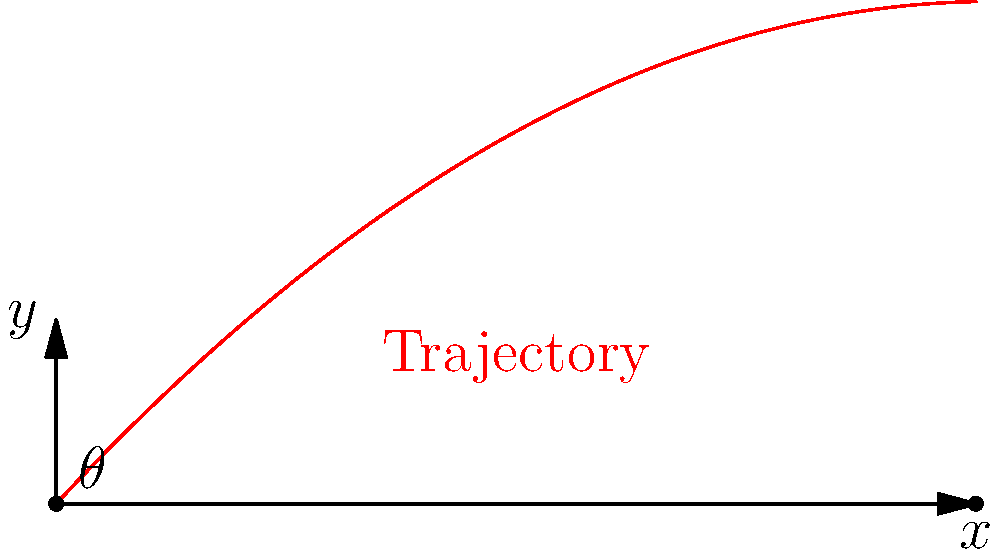As a shooting coach, you're training a Paralympic athlete for a long-range target event. The athlete needs to hit a target 500 meters away using a specialized air rifle with an initial velocity of 100 m/s. Neglecting air resistance, what is the optimal firing angle (in degrees) to hit the target? To solve this problem, we'll use the equation for the optimal angle when air resistance is neglected:

$$\theta = \frac{1}{2}\arcsin(\frac{gd}{v_0^2})$$

Where:
$\theta$ is the optimal angle
$g$ is the acceleration due to gravity (9.8 m/s²)
$d$ is the horizontal distance to the target (500 m)
$v_0$ is the initial velocity (100 m/s)

Step 1: Substitute the values into the equation:
$$\theta = \frac{1}{2}\arcsin(\frac{9.8 \times 500}{100^2})$$

Step 2: Simplify the fraction inside the arcsin:
$$\theta = \frac{1}{2}\arcsin(\frac{4900}{10000}) = \frac{1}{2}\arcsin(0.49)$$

Step 3: Calculate the arcsin:
$$\theta = \frac{1}{2} \times 29.33^\circ$$

Step 4: Multiply by 1/2:
$$\theta = 14.67^\circ$$

Therefore, the optimal firing angle is approximately 14.67 degrees.
Answer: 14.67° 